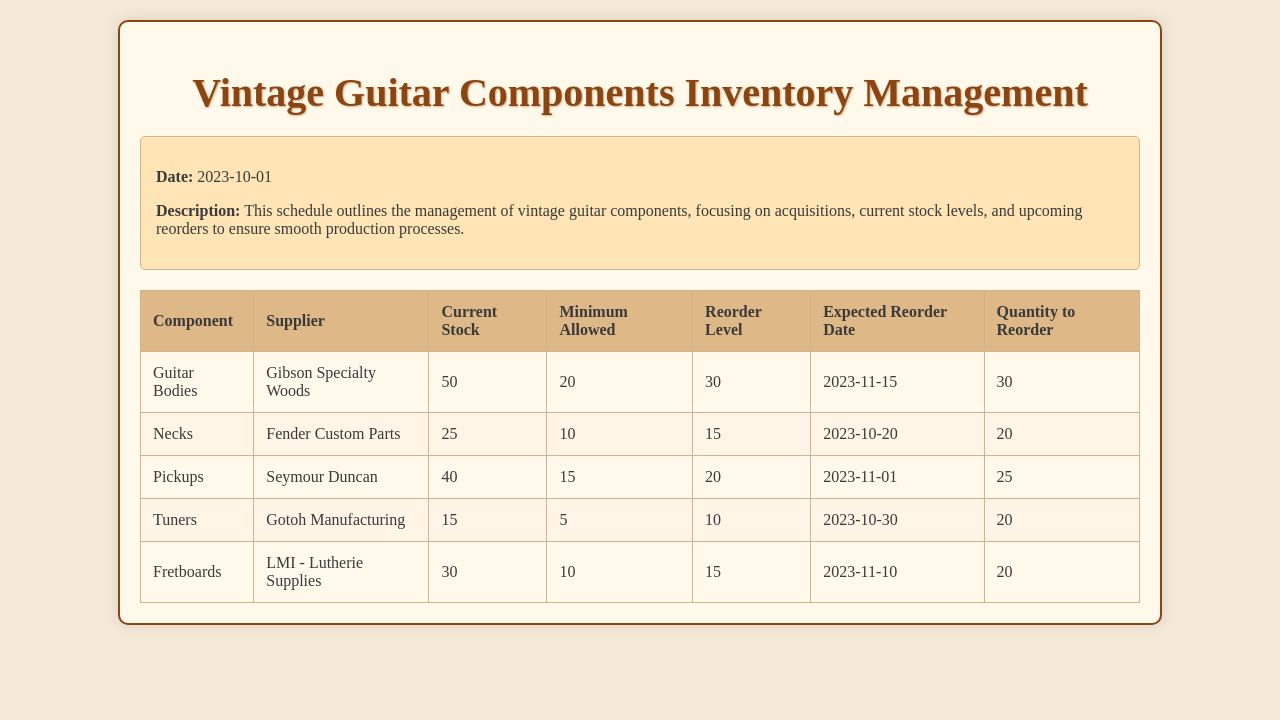What is the current stock level of Necks? The current stock level of Necks is provided in the document, which states it is 25.
Answer: 25 What is the expected reorder date for Tuners? The document lists the expected reorder date for Tuners as 2023-10-30.
Answer: 2023-10-30 Who is the supplier for Fretboards? The document specifies that the supplier for Fretboards is LMI - Lutherie Supplies.
Answer: LMI - Lutherie Supplies What is the minimum allowed stock for Pickups? The minimum allowed stock for Pickups is stated as 15 in the document.
Answer: 15 How many Guitar Bodies are planned to be reordered? The document indicates that 30 Guitar Bodies are planned to be reordered.
Answer: 30 Which components are marked for reorder soon? The document highlights Necks and Tuners as components that are marked for reorder soon due to their stock levels.
Answer: Necks, Tuners What is the reorder level for Pickups? The reorder level for Pickups is indicated in the document as 20.
Answer: 20 What is the total quantity to reorder for all components? The total quantity to reorder is calculated by summing the quantities to reorder for all components listed in the document.
Answer: 115 When was the inventory management schedule last updated? The date mentioned in the overview section indicates that the schedule was last updated on 2023-10-01.
Answer: 2023-10-01 